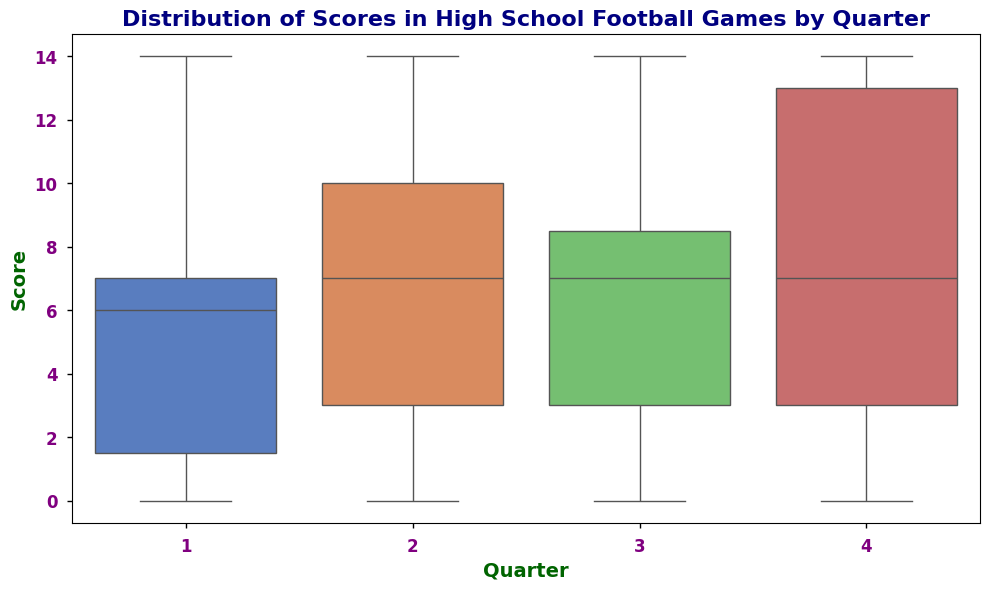What's the median score in the first quarter? To find the median of the first quarter, we need to list the scores, sort them, and find the middle value. The sorted scores are [0, 0, 0, 3, 3, 3, 6, 7, 7, 7, 7, 10, 10, 14]. With 14 values, the median is the average of the 7th and 8th values. So, (6 + 7)/2 = 6.5
Answer: 6.5 Which quarter has the highest average score? To identify this, calculate the mean score for each quarter and compare. Quarter 1: (7+3+0+7+10+6+14+3+0+7+7+0+3+10+0)/15 = 5.533. Quarter 2: (14+7+3+6+7+14+10+3+0+7+13+3+10+0+7)/15 = 6.6. Quarter 3: (14+7+3+6+7+0+10+3+7+0+7+14+3+10+7)/15 = 6.13. Quarter 4: (14+7+3+0+7+10+14+3+0+14+10+7+3+14)/14 = 7.93. Quarter 4 has the highest average score.
Answer: Quarter 4 What's the interquartile range (IQR) for scores in the third quarter? The interquartile range is Q3 - Q1. Sort scores: [0, 0, 3, 3, 3, 3, 6, 7, 7, 7, 7, 10, 10, 14]. Q1 (25th percentile) is the 4th value (3), and Q3 (75th percentile) is the 11th value (7). IQR: 7 - 3 = 4
Answer: 4 In which quarter is the range of scores the widest? The range is the difference between the maximum and minimum scores in each quarter. Quarter 1: 14 - 0 = 14. Quarter 2: 14 - 0 = 14. Quarter 3: 14 - 0 = 14. Quarter 4: 14 - 0 = 14. All quarters have the same range of 14.
Answer: All quarters How does the median score of the fourth quarter compare to the second quarter? The median for each quarter is the middle value. Medians: Q1: 6.5, Q2: 7, Q3: 7, Q4: 7. Compare Q4 and Q2, both have a median of 7, so they are equal.
Answer: Equal Which quarter has the most outliers? Outliers are scores that fall significantly higher or lower than the rest of the data. Look for any points outside the whiskers in the box plot. If no special indication, guess by distribution. No clear answer just by guesswork should be assumed if the graph isn't detailed.
Answer: Not Discernible 